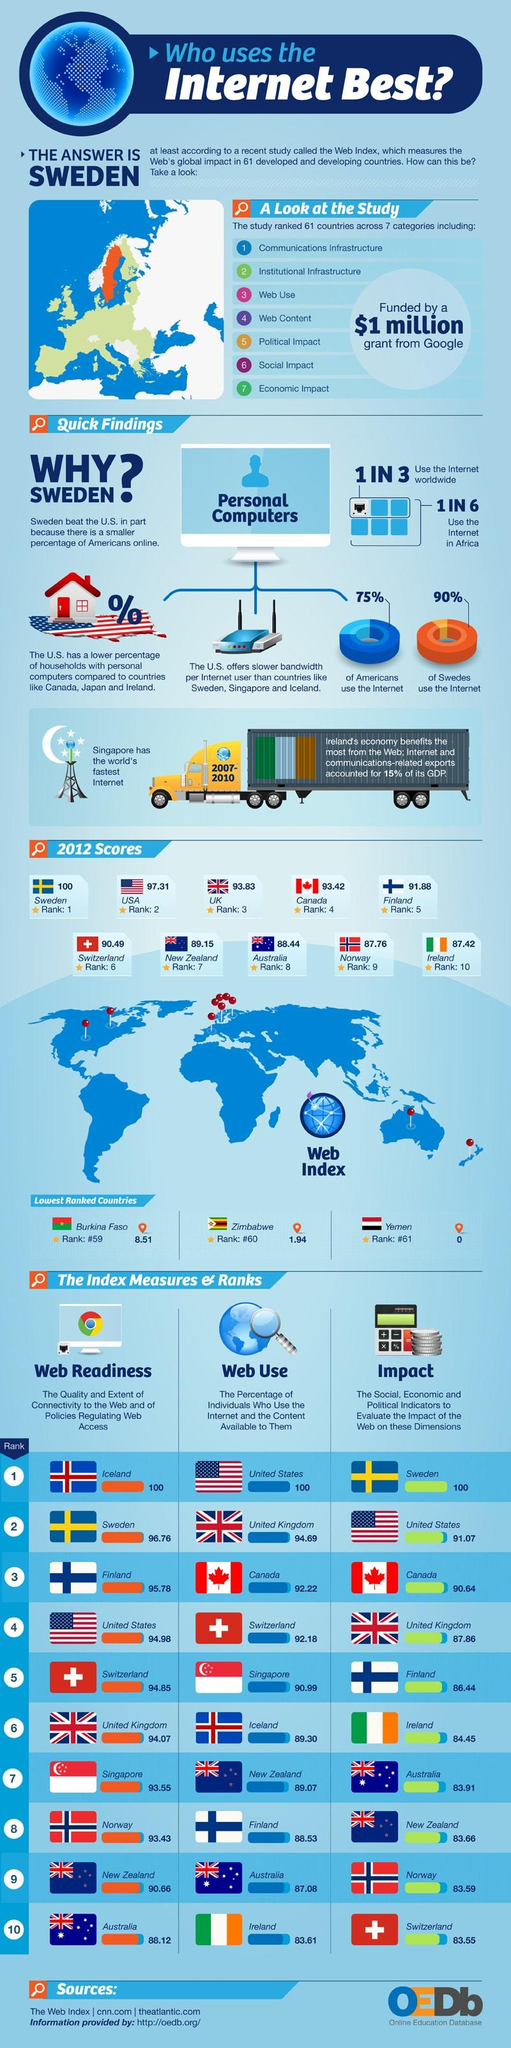Specify some key components in this picture. The country with the second highest web index score among the given countries in 2012 was the United States of America. According to the web index score of Canada in 2012, the country had a score of 93.42. According to the World Wide Web Foundation's Web Index score for 2012, the United Kingdom had a web index score of 93.83, indicating a high level of access to the internet and digital technologies in the country. Ninety percent of Swedes use the internet, according to recent statistics. According to a recent survey, 25% of Americans do not use the internet. 